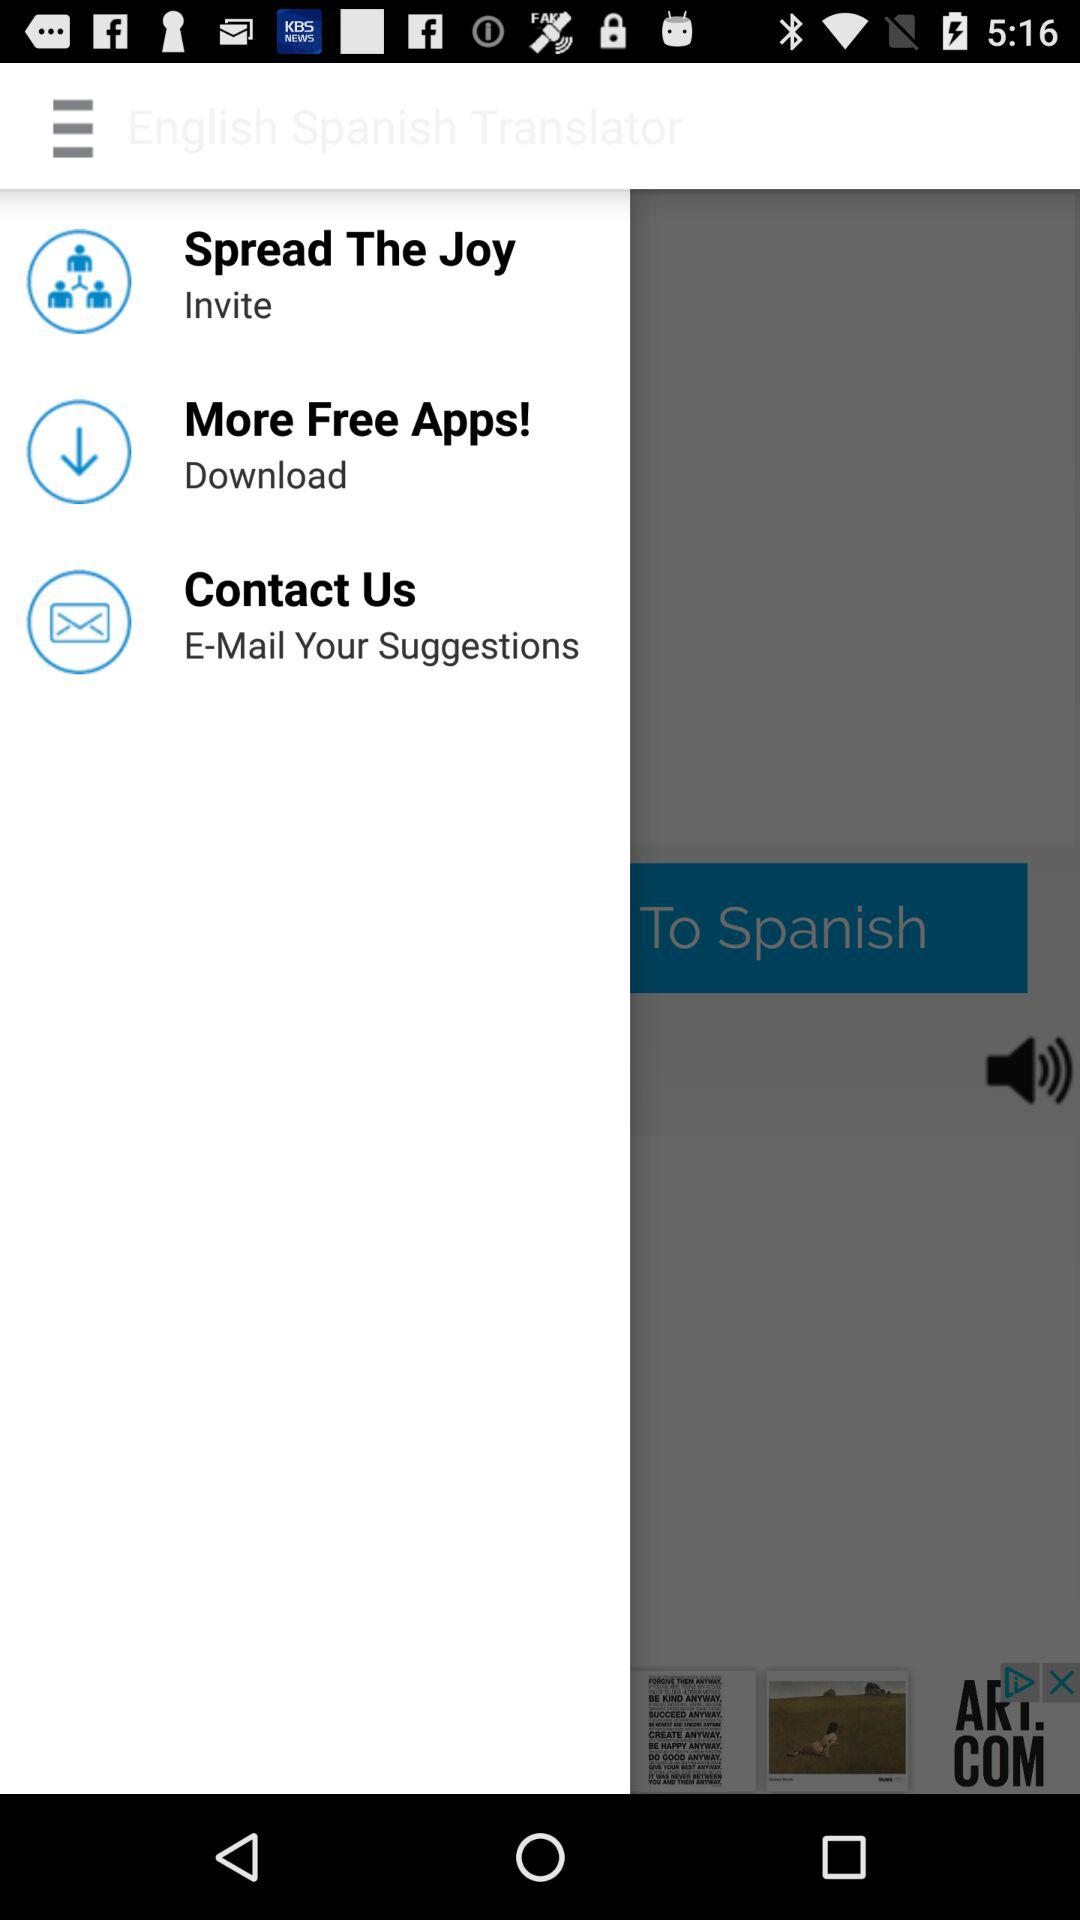What is the name of the application? The name of the application is "English Spanish Translator". 